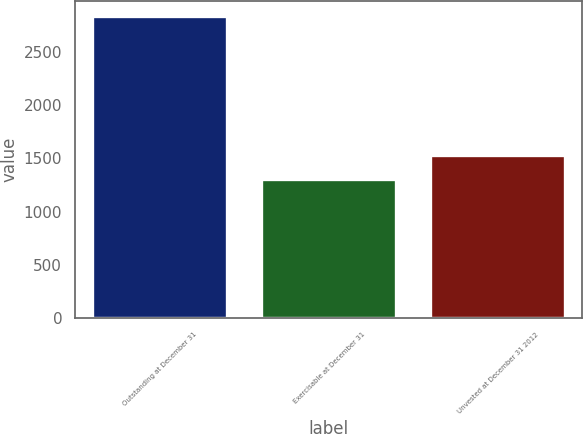<chart> <loc_0><loc_0><loc_500><loc_500><bar_chart><fcel>Outstanding at December 31<fcel>Exercisable at December 31<fcel>Unvested at December 31 2012<nl><fcel>2831<fcel>1305<fcel>1526<nl></chart> 